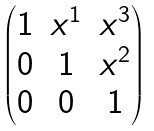<formula> <loc_0><loc_0><loc_500><loc_500>\begin{pmatrix} 1 & x ^ { 1 } & x ^ { 3 } \\ 0 & 1 & x ^ { 2 } \\ 0 & 0 & 1 \end{pmatrix}</formula> 